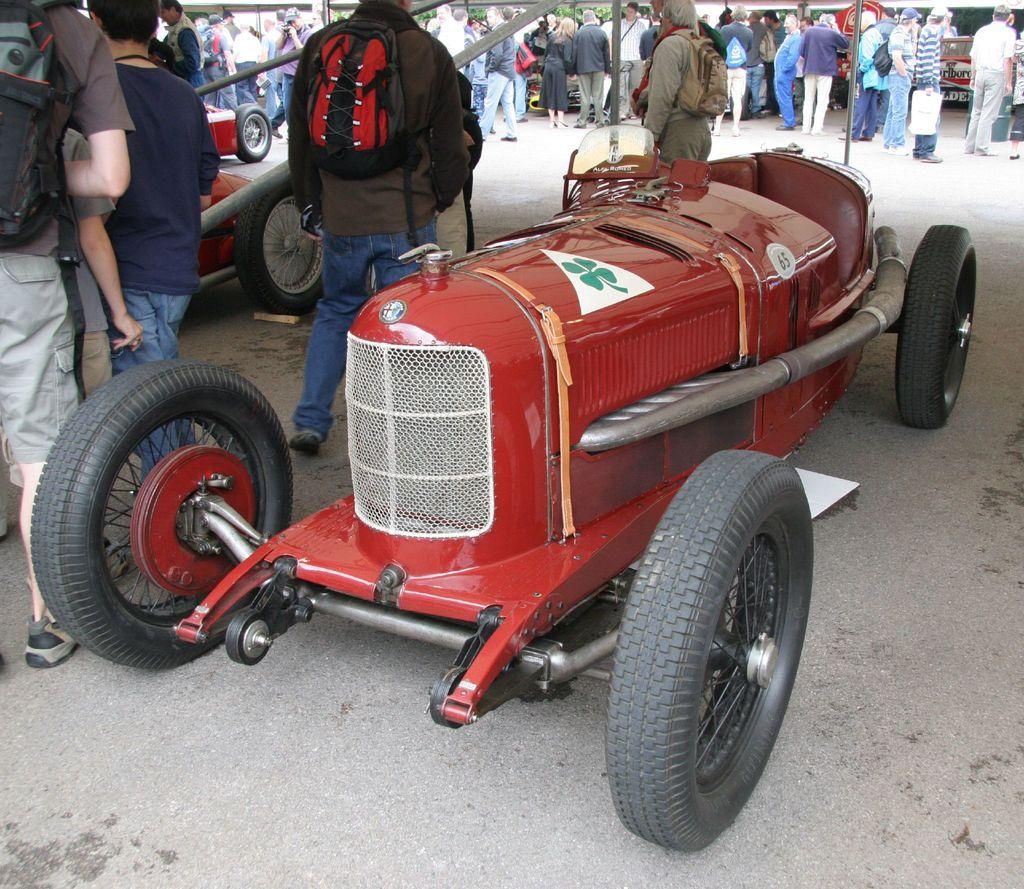What types of objects are present in the image? There are vehicles and people in the image. What are some people doing in the image? Some people are wearing bags in the image. Can you describe any specific features of the vehicles? There is a logo on at least one vehicle in the image. What else can be seen in the image besides vehicles and people? There are poles in the image. What crime is being committed in the image? There is no indication of a crime being committed in the image. How many times are the people kicking the vehicles in the image? There are no instances of people kicking vehicles in the image. 